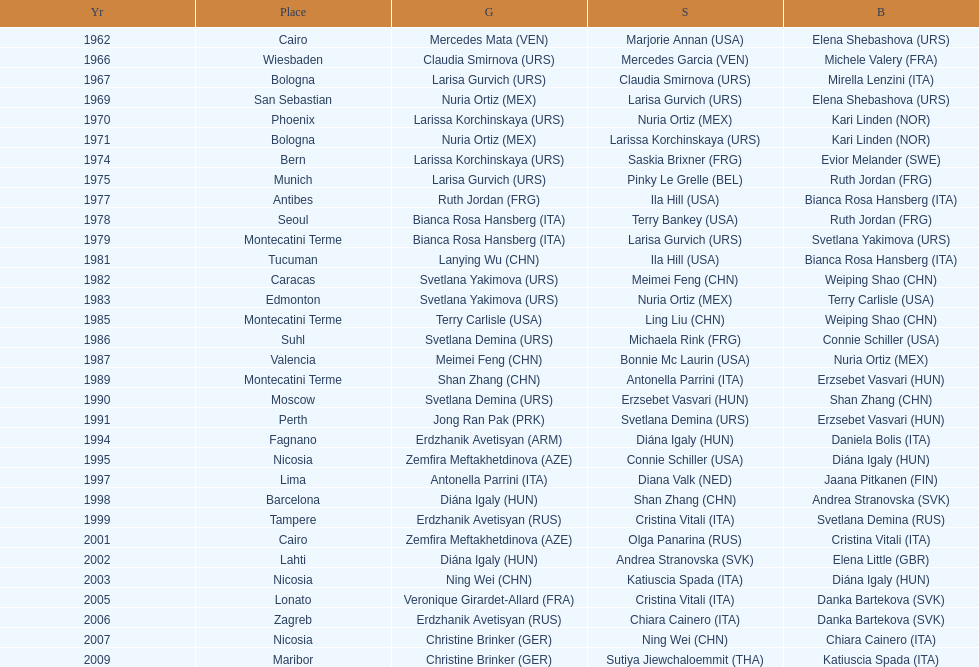How many gold did u.s.a win 1. 